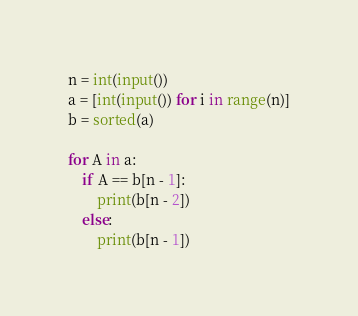Convert code to text. <code><loc_0><loc_0><loc_500><loc_500><_Python_>n = int(input())
a = [int(input()) for i in range(n)]
b = sorted(a)

for A in a:
    if A == b[n - 1]:
        print(b[n - 2])
    else:
        print(b[n - 1])</code> 